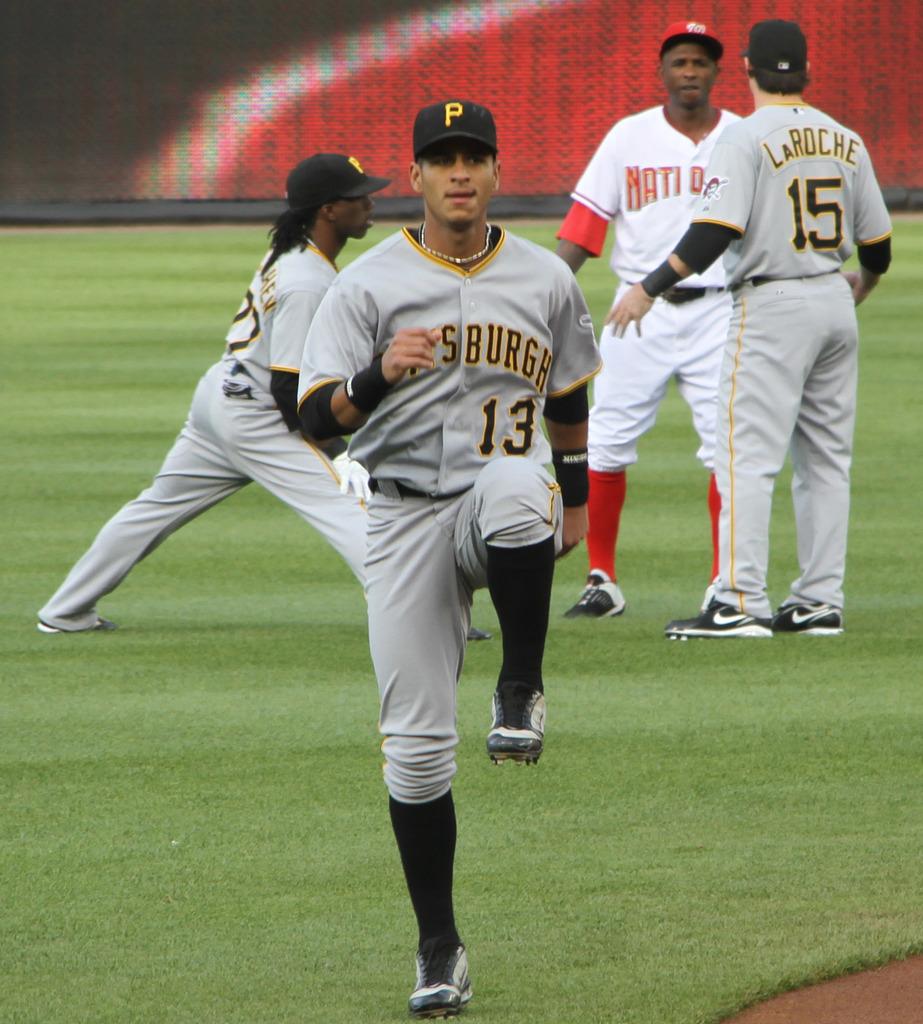What is the number on the back of laroche's jersey?
Provide a short and direct response. 15. 